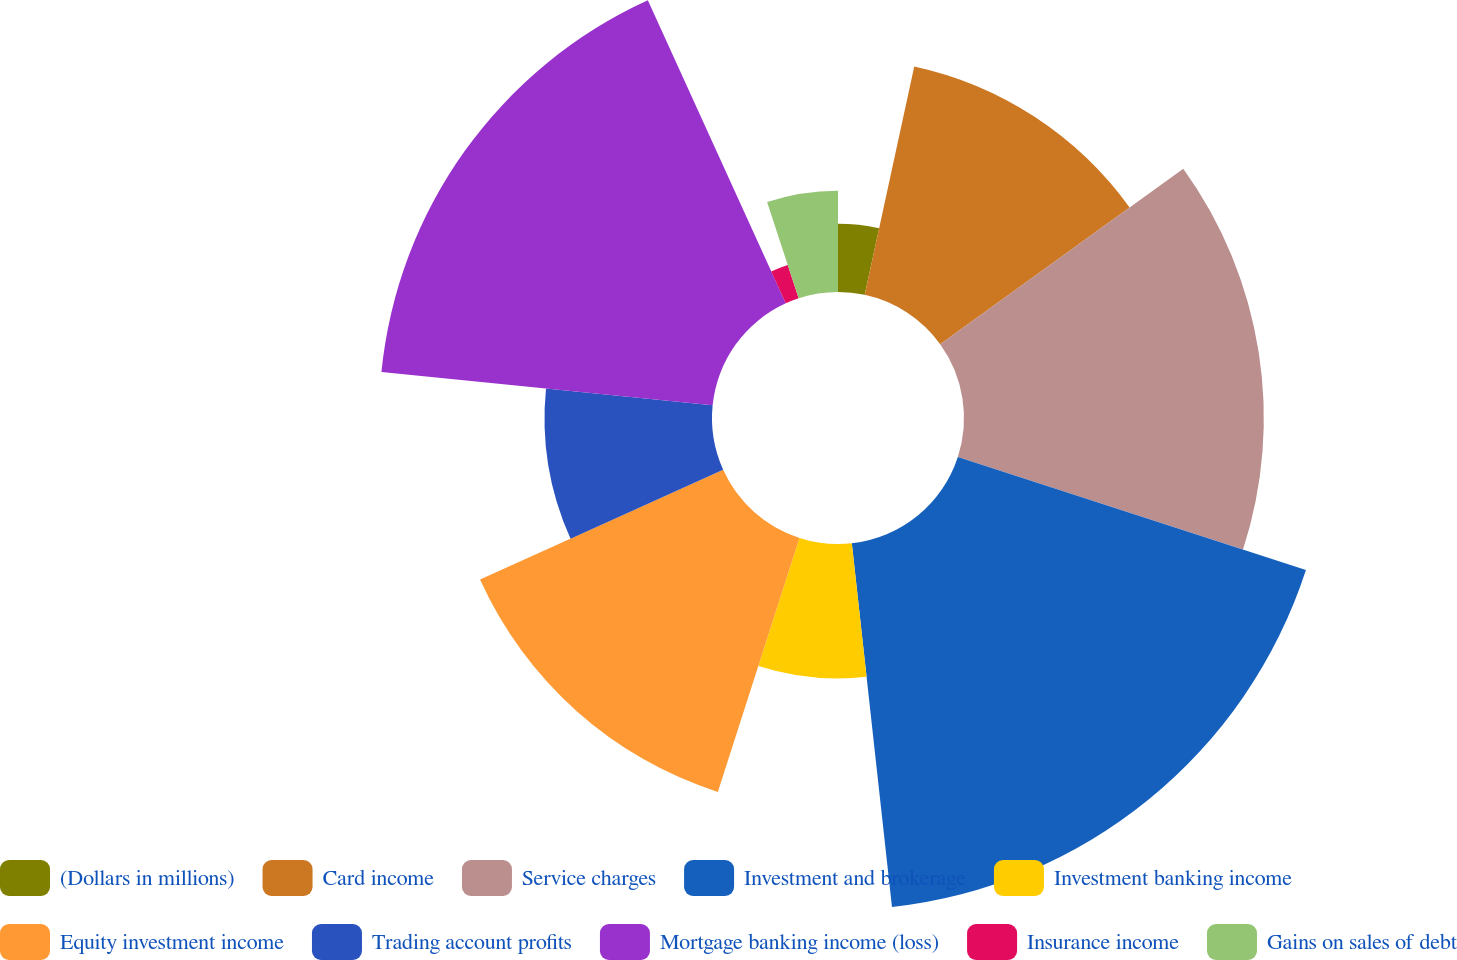<chart> <loc_0><loc_0><loc_500><loc_500><pie_chart><fcel>(Dollars in millions)<fcel>Card income<fcel>Service charges<fcel>Investment and brokerage<fcel>Investment banking income<fcel>Equity investment income<fcel>Trading account profits<fcel>Mortgage banking income (loss)<fcel>Insurance income<fcel>Gains on sales of debt<nl><fcel>3.4%<fcel>11.65%<fcel>14.95%<fcel>18.25%<fcel>6.7%<fcel>13.3%<fcel>8.35%<fcel>16.6%<fcel>1.75%<fcel>5.05%<nl></chart> 